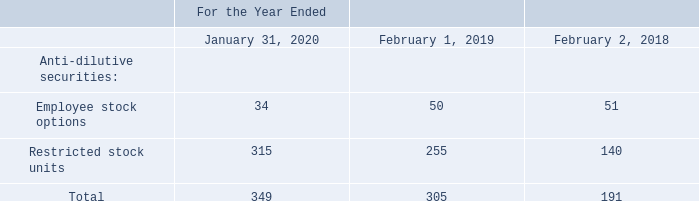H. Net Income Per Share
Basic net income per share is computed by dividing net income by the weighted-average number of common stock outstanding during the period. Diluted net income per share is computed by dividing net income by the weighted-average number of common stock outstanding and potentially dilutive securities outstanding during the period, as calculated using the treasury stock method. Potentially dilutive securities primarily include unvested restricted stock units (“RSUs”), including PSU awards, and stock options, including purchase options under VMware’s employee stock purchase plan, which included Pivotal’s employee stock purchase plan through the date of acquisition. Securities are excluded from the computation of diluted net income per share if their effect would be anti-dilutive. VMware uses the two-class method to calculate net income per share as both classes share the same rights in dividends; therefore, basic and diluted earnings per share are the same for both classes.
The following table sets forth the weighted-average common share equivalents of Class A common stock that were excluded from the diluted net income per share calculations during the periods presented because their effect would have been anti-dilutive (shares in thousands):
Which years does the table provide information for the weighted-average common share equivalents of Class A common stock that were excluded from the diluted net income per share calculations? 2020, 2019, 2018. What was the Employee stock options in 2019?
Answer scale should be: thousand. 50. What were the Restricted stock units in 2018?
Answer scale should be: thousand. 140. What was the change in employee stock options between 2018 and 2019?
Answer scale should be: thousand. 50-51
Answer: -1. How many years did Restricted stock units exceed $200 thousand? 2020##2019
Answer: 2. What was the percentage change in the total anti-dilutive securities between 2019 and 2020?
Answer scale should be: percent. (349-305)/305
Answer: 14.43. 